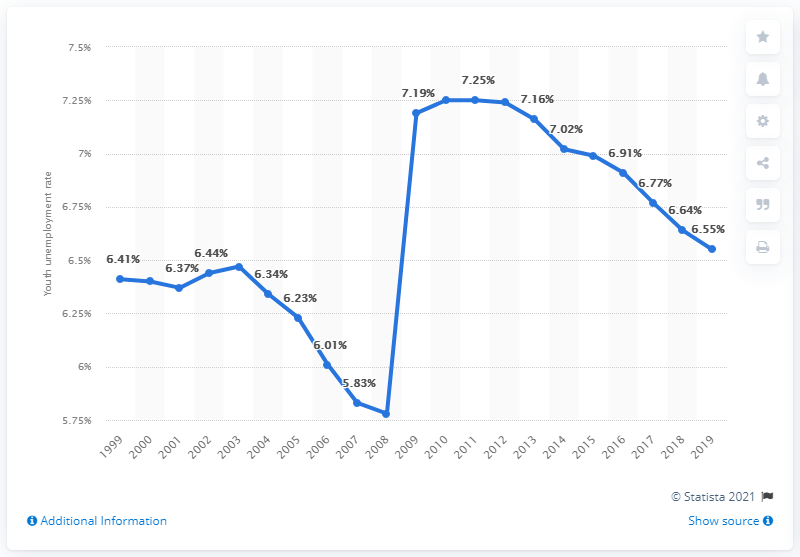Highlight a few significant elements in this photo. The youth unemployment rate in the Central African Republic in 2019 was 6.55%. 